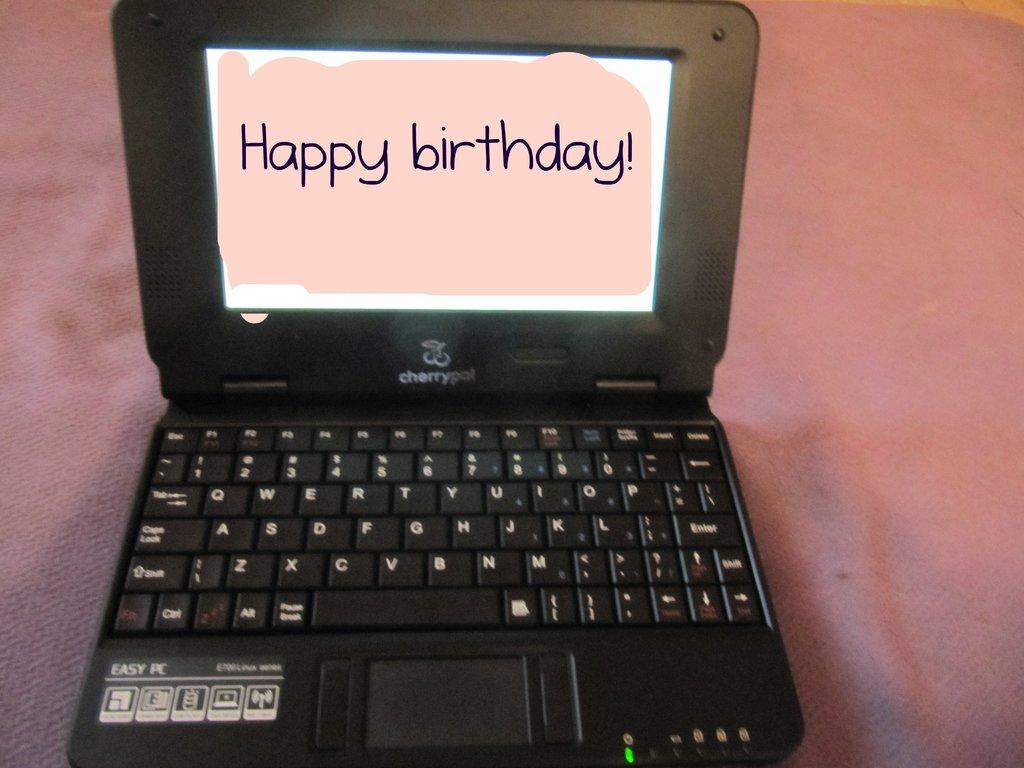<image>
Provide a brief description of the given image. A laptop with the words displaying Happy Birthday covering the screen. 